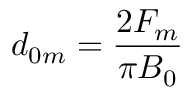<formula> <loc_0><loc_0><loc_500><loc_500>d _ { 0 m } = \frac { 2 F _ { m } } { \pi B _ { 0 } }</formula> 